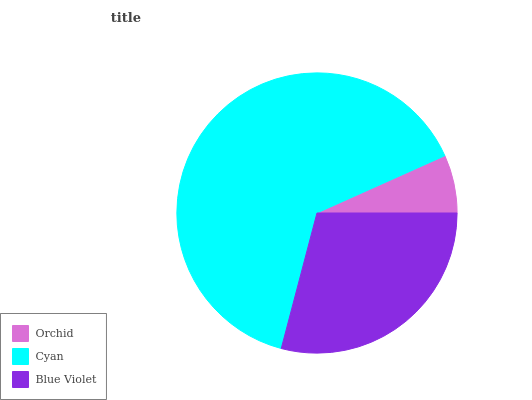Is Orchid the minimum?
Answer yes or no. Yes. Is Cyan the maximum?
Answer yes or no. Yes. Is Blue Violet the minimum?
Answer yes or no. No. Is Blue Violet the maximum?
Answer yes or no. No. Is Cyan greater than Blue Violet?
Answer yes or no. Yes. Is Blue Violet less than Cyan?
Answer yes or no. Yes. Is Blue Violet greater than Cyan?
Answer yes or no. No. Is Cyan less than Blue Violet?
Answer yes or no. No. Is Blue Violet the high median?
Answer yes or no. Yes. Is Blue Violet the low median?
Answer yes or no. Yes. Is Cyan the high median?
Answer yes or no. No. Is Cyan the low median?
Answer yes or no. No. 